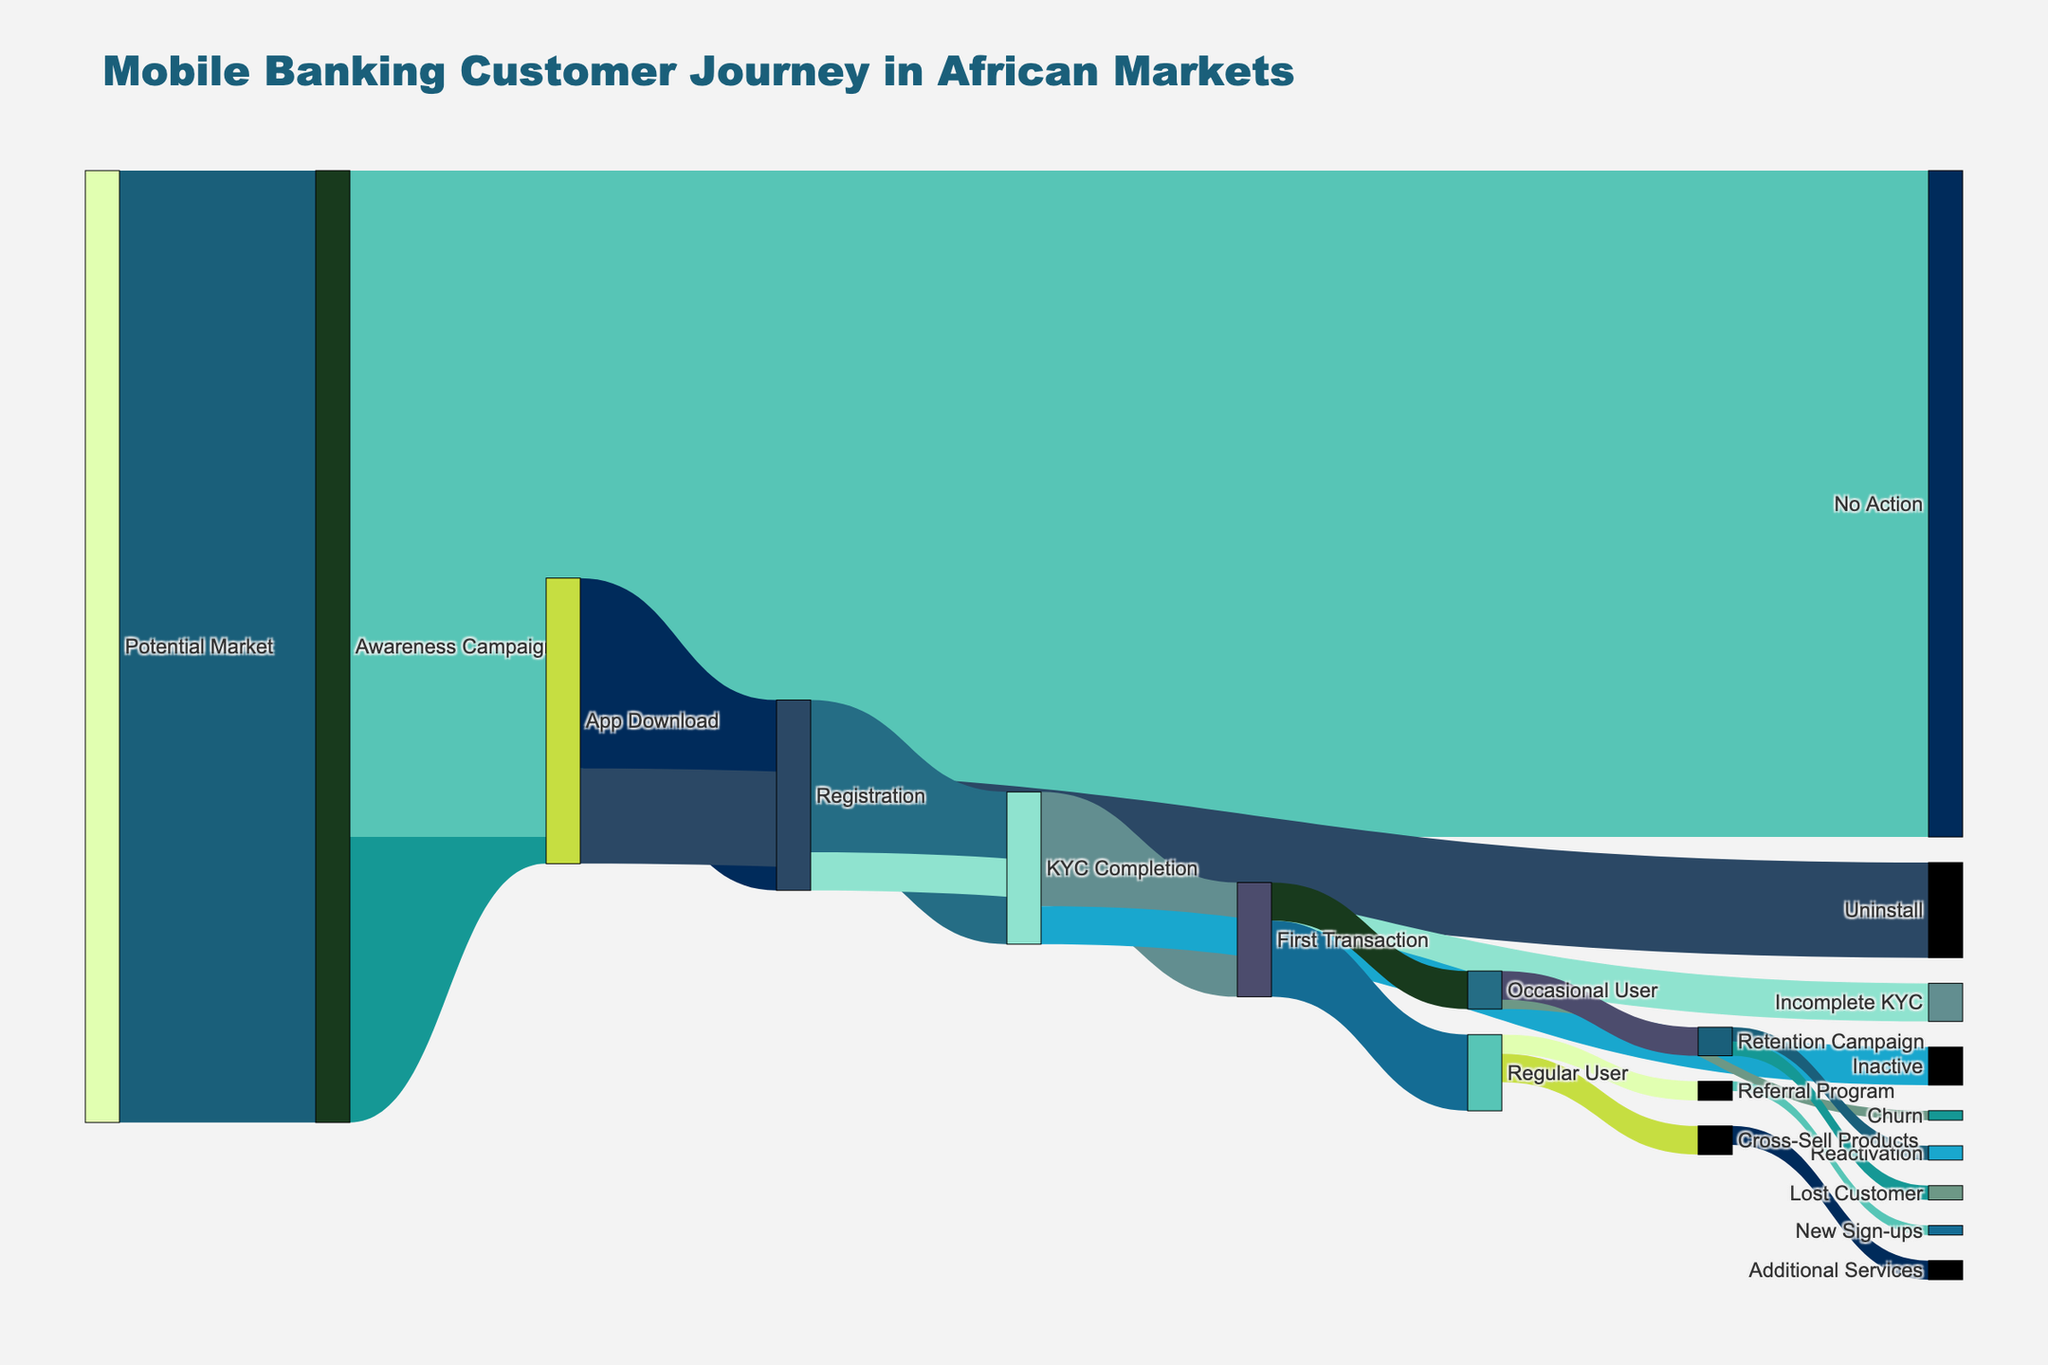what is the value of users transitioning from App Download to Registration? The Sankey diagram shows the value of users flowing from 'App Download' to 'Registration'. By looking at the chart, the value is 1,000,000.
Answer: 1,000,000 Which two flows have the highest drop-off from one step to the next? By observing the figure, the largest drop-offs are from 'Potential Market' to 'Awareness Campaign' (5,000,000) and from 'Awareness Campaign' to 'No Action' (3,500,000).
Answer: 'Potential Market' to 'Awareness Campaign' and 'Awareness Campaign' to 'No Action' How many users completed KYC after registration? To determine how many users completed KYC, look at the flow from 'Registration' to 'KYC Completion' in the chart. The value is 800,000.
Answer: 800,000 What is the total value of users who become active users (both regular and occasional) after their first transaction? Combine the values flowing from 'First Transaction' to 'Regular User' (400,000) and 'First Transaction' to 'Occasional User' (200,000): 400,000 + 200,000 = 600,000.
Answer: 600,000 Which flow has the smallest value, and what is that value? The chart shows that the flow with the smallest value is from the 'Referral Program' to 'New Sign-ups' with a value of 50,000.
Answer: Referral Program to New sign-ups, 50,000 How many users are retained (remain active or reactivated) after entering the retention campaign? Combine the values from 'Retention Campaign' to 'Reactivation' (75,000) and from 'Retention Campaign' to 'Inactive Users' (75,000). The total retained users equal 75,000 + 75,000 = 150,000.
Answer: 150,000 How does the number of users completing KYC compare to those who become regular users? The number of users who completed KYC is 800,000, whereas the number who became regular users is 400,000. This shows there are twice as many users completing KYC as those becoming regular users.
Answer: KYC Completion is 2 times Regular Users 